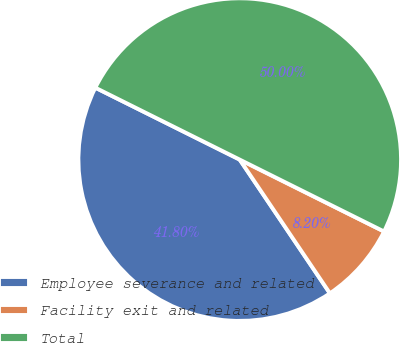<chart> <loc_0><loc_0><loc_500><loc_500><pie_chart><fcel>Employee severance and related<fcel>Facility exit and related<fcel>Total<nl><fcel>41.8%<fcel>8.2%<fcel>50.0%<nl></chart> 